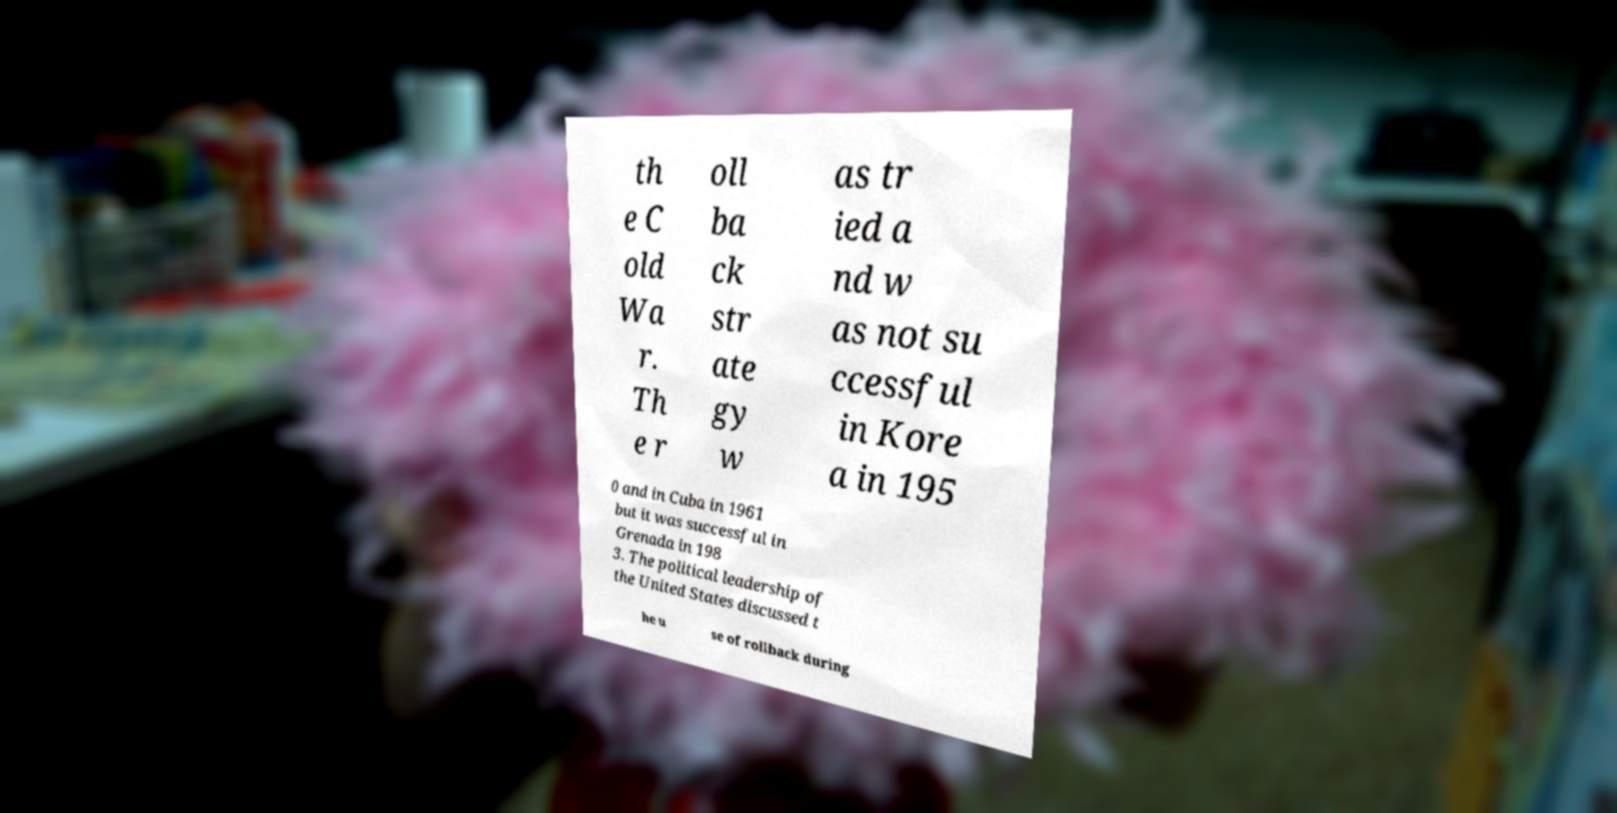Could you assist in decoding the text presented in this image and type it out clearly? th e C old Wa r. Th e r oll ba ck str ate gy w as tr ied a nd w as not su ccessful in Kore a in 195 0 and in Cuba in 1961 but it was successful in Grenada in 198 3. The political leadership of the United States discussed t he u se of rollback during 